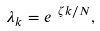<formula> <loc_0><loc_0><loc_500><loc_500>\lambda _ { k } = e ^ { \ \zeta k / N } ,</formula> 